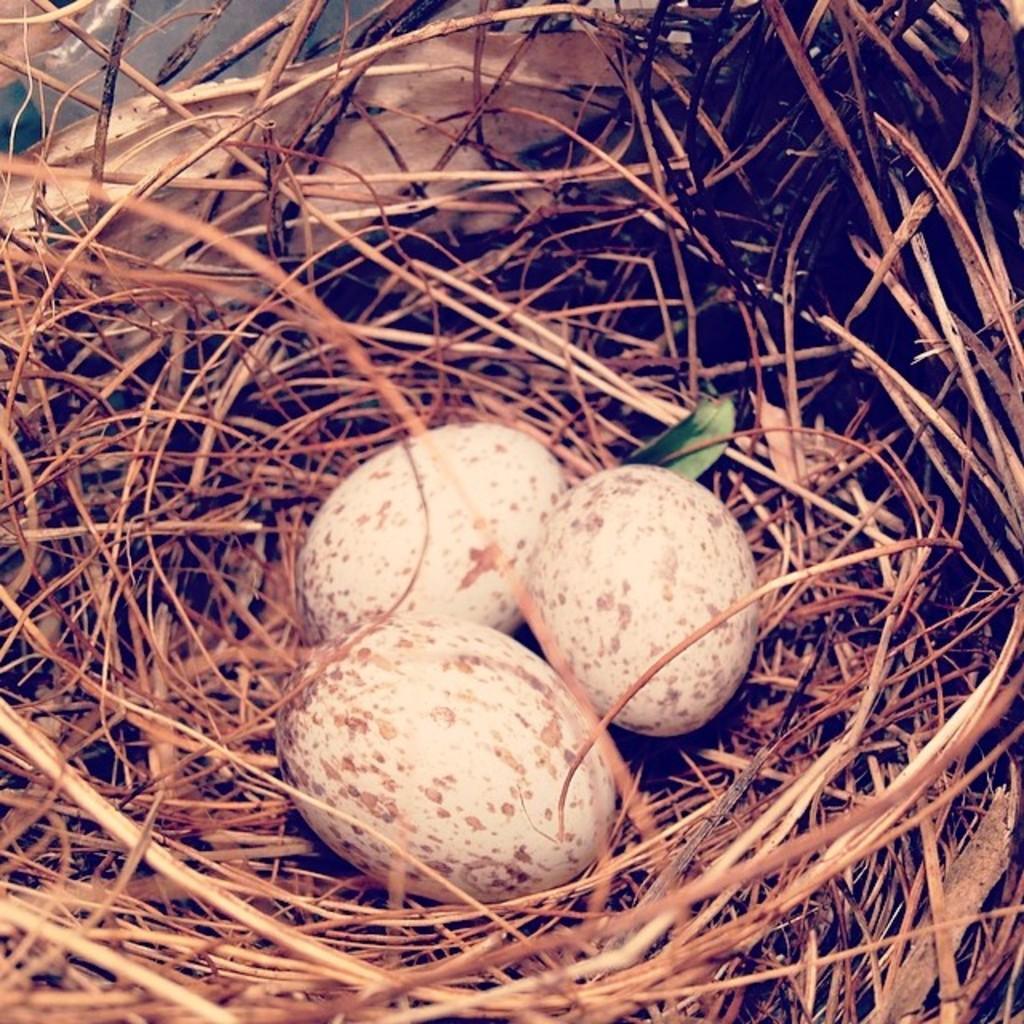Can you describe this image briefly? In this picture we can see there are three eggs in the nest. 